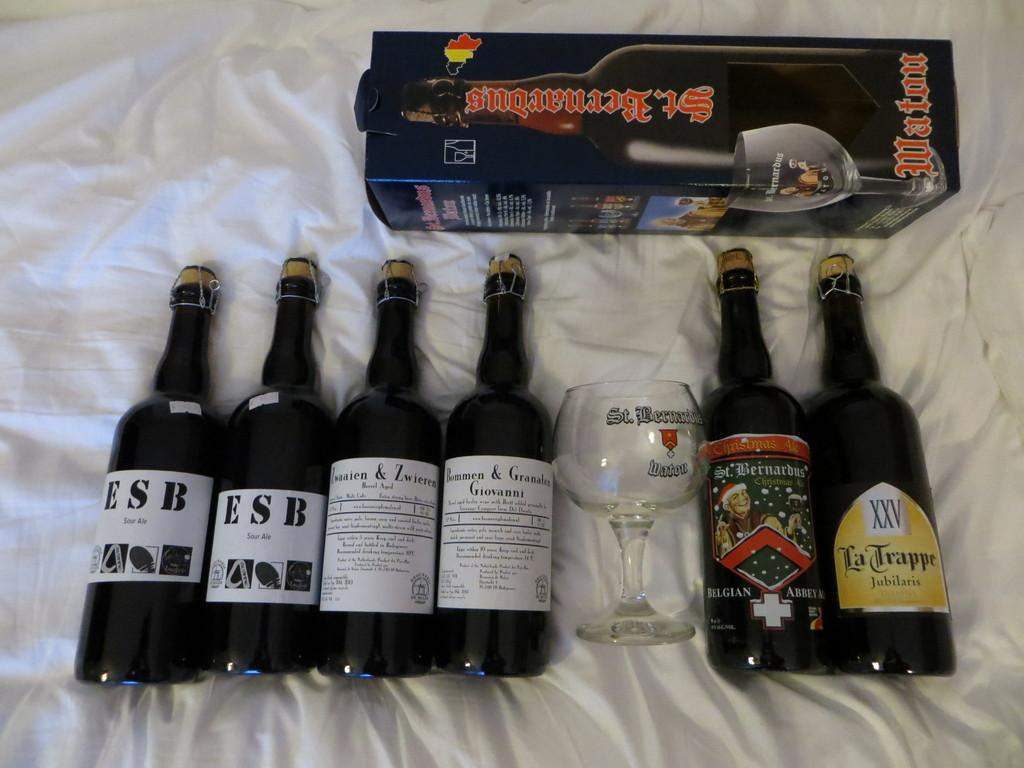<image>
Relay a brief, clear account of the picture shown. Six wine bottles with middle one having "Bommen Granaten Giovanni" written on it 